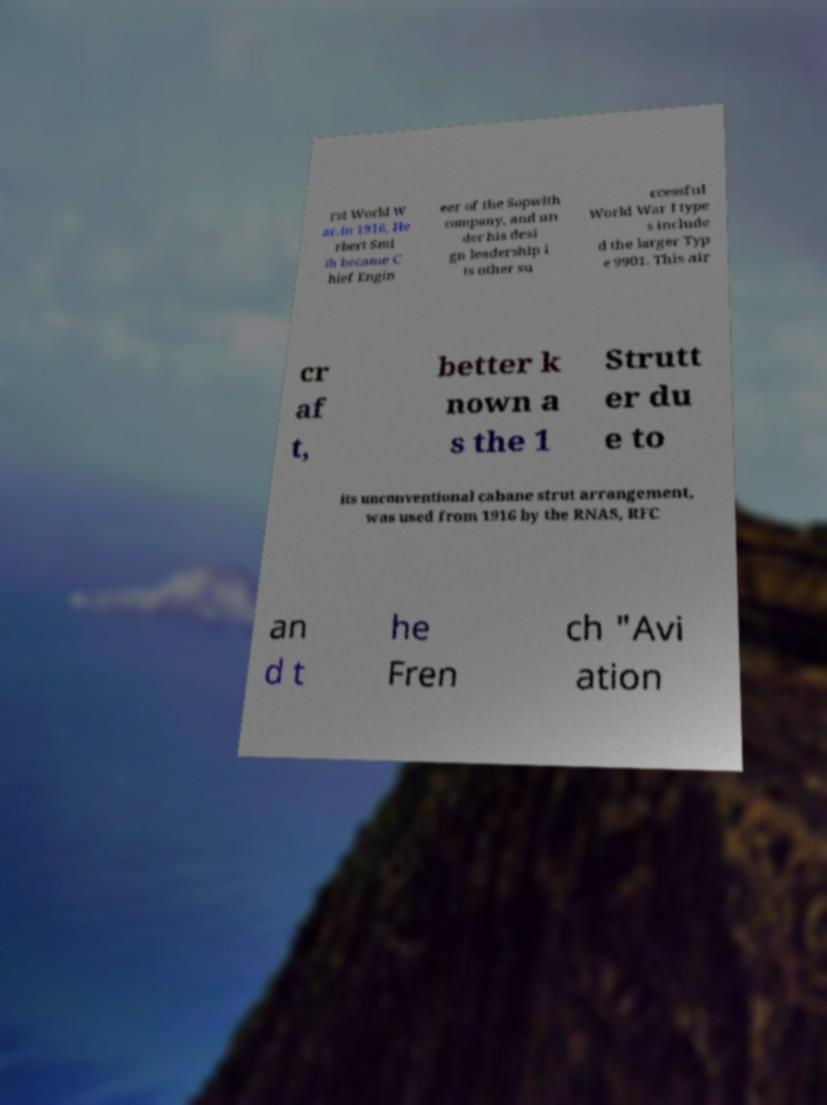What messages or text are displayed in this image? I need them in a readable, typed format. rst World W ar.In 1916, He rbert Smi th became C hief Engin eer of the Sopwith company, and un der his desi gn leadership i ts other su ccessful World War I type s include d the larger Typ e 9901. This air cr af t, better k nown a s the 1 Strutt er du e to its unconventional cabane strut arrangement, was used from 1916 by the RNAS, RFC an d t he Fren ch "Avi ation 